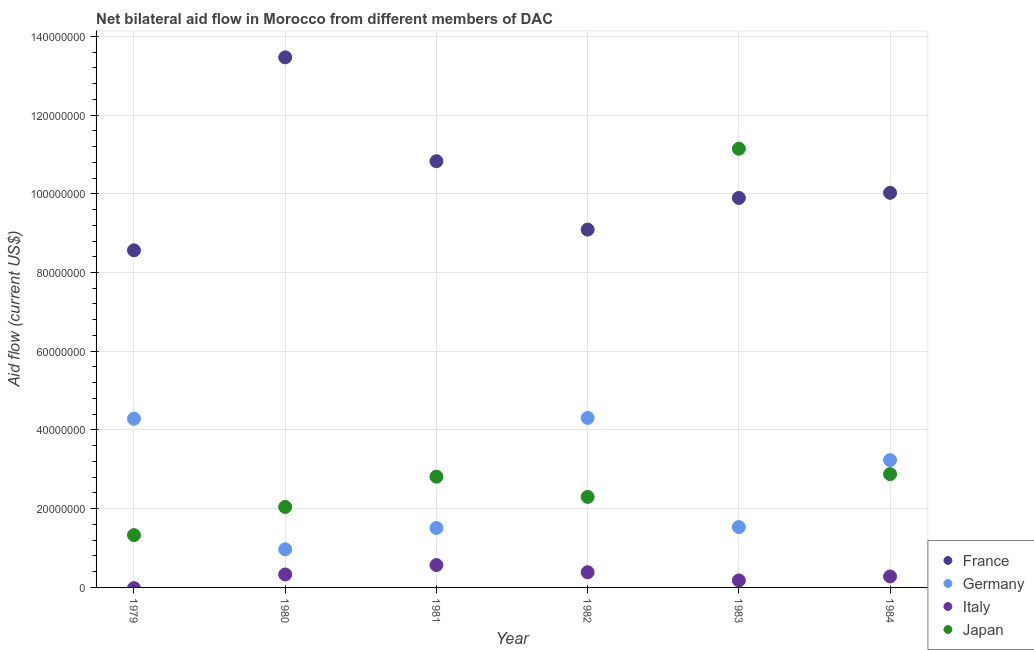What is the amount of aid given by france in 1980?
Your response must be concise. 1.35e+08. Across all years, what is the maximum amount of aid given by italy?
Make the answer very short. 5.68e+06. Across all years, what is the minimum amount of aid given by japan?
Give a very brief answer. 1.33e+07. What is the total amount of aid given by italy in the graph?
Your answer should be very brief. 1.74e+07. What is the difference between the amount of aid given by france in 1982 and that in 1984?
Ensure brevity in your answer.  -9.34e+06. What is the difference between the amount of aid given by italy in 1979 and the amount of aid given by japan in 1980?
Keep it short and to the point. -2.04e+07. What is the average amount of aid given by japan per year?
Keep it short and to the point. 3.75e+07. In the year 1984, what is the difference between the amount of aid given by japan and amount of aid given by germany?
Your answer should be very brief. -3.55e+06. In how many years, is the amount of aid given by germany greater than 96000000 US$?
Ensure brevity in your answer.  0. What is the ratio of the amount of aid given by france in 1981 to that in 1983?
Make the answer very short. 1.09. What is the difference between the highest and the second highest amount of aid given by japan?
Offer a very short reply. 8.27e+07. What is the difference between the highest and the lowest amount of aid given by france?
Provide a short and direct response. 4.90e+07. In how many years, is the amount of aid given by japan greater than the average amount of aid given by japan taken over all years?
Give a very brief answer. 1. Is the sum of the amount of aid given by italy in 1981 and 1984 greater than the maximum amount of aid given by france across all years?
Your answer should be compact. No. Is it the case that in every year, the sum of the amount of aid given by france and amount of aid given by japan is greater than the sum of amount of aid given by germany and amount of aid given by italy?
Make the answer very short. Yes. Is it the case that in every year, the sum of the amount of aid given by france and amount of aid given by germany is greater than the amount of aid given by italy?
Offer a terse response. Yes. Does the amount of aid given by france monotonically increase over the years?
Provide a short and direct response. No. Is the amount of aid given by italy strictly less than the amount of aid given by japan over the years?
Keep it short and to the point. Yes. Are the values on the major ticks of Y-axis written in scientific E-notation?
Make the answer very short. No. Does the graph contain any zero values?
Keep it short and to the point. Yes. Does the graph contain grids?
Provide a succinct answer. Yes. How many legend labels are there?
Keep it short and to the point. 4. How are the legend labels stacked?
Your response must be concise. Vertical. What is the title of the graph?
Give a very brief answer. Net bilateral aid flow in Morocco from different members of DAC. Does "Germany" appear as one of the legend labels in the graph?
Provide a short and direct response. Yes. What is the label or title of the Y-axis?
Your answer should be very brief. Aid flow (current US$). What is the Aid flow (current US$) of France in 1979?
Offer a very short reply. 8.56e+07. What is the Aid flow (current US$) in Germany in 1979?
Make the answer very short. 4.28e+07. What is the Aid flow (current US$) in Italy in 1979?
Keep it short and to the point. 0. What is the Aid flow (current US$) in Japan in 1979?
Give a very brief answer. 1.33e+07. What is the Aid flow (current US$) of France in 1980?
Your answer should be very brief. 1.35e+08. What is the Aid flow (current US$) of Germany in 1980?
Give a very brief answer. 9.69e+06. What is the Aid flow (current US$) in Italy in 1980?
Ensure brevity in your answer.  3.29e+06. What is the Aid flow (current US$) of Japan in 1980?
Your answer should be very brief. 2.04e+07. What is the Aid flow (current US$) of France in 1981?
Your answer should be compact. 1.08e+08. What is the Aid flow (current US$) of Germany in 1981?
Your answer should be compact. 1.51e+07. What is the Aid flow (current US$) in Italy in 1981?
Ensure brevity in your answer.  5.68e+06. What is the Aid flow (current US$) in Japan in 1981?
Offer a terse response. 2.81e+07. What is the Aid flow (current US$) of France in 1982?
Your answer should be very brief. 9.09e+07. What is the Aid flow (current US$) of Germany in 1982?
Offer a terse response. 4.30e+07. What is the Aid flow (current US$) of Italy in 1982?
Your response must be concise. 3.86e+06. What is the Aid flow (current US$) of Japan in 1982?
Offer a terse response. 2.30e+07. What is the Aid flow (current US$) in France in 1983?
Your answer should be compact. 9.89e+07. What is the Aid flow (current US$) in Germany in 1983?
Your response must be concise. 1.53e+07. What is the Aid flow (current US$) of Italy in 1983?
Provide a short and direct response. 1.78e+06. What is the Aid flow (current US$) in Japan in 1983?
Your answer should be very brief. 1.11e+08. What is the Aid flow (current US$) in France in 1984?
Make the answer very short. 1.00e+08. What is the Aid flow (current US$) in Germany in 1984?
Keep it short and to the point. 3.23e+07. What is the Aid flow (current US$) in Italy in 1984?
Your answer should be very brief. 2.79e+06. What is the Aid flow (current US$) of Japan in 1984?
Ensure brevity in your answer.  2.88e+07. Across all years, what is the maximum Aid flow (current US$) in France?
Ensure brevity in your answer.  1.35e+08. Across all years, what is the maximum Aid flow (current US$) in Germany?
Keep it short and to the point. 4.30e+07. Across all years, what is the maximum Aid flow (current US$) in Italy?
Offer a very short reply. 5.68e+06. Across all years, what is the maximum Aid flow (current US$) in Japan?
Give a very brief answer. 1.11e+08. Across all years, what is the minimum Aid flow (current US$) of France?
Offer a terse response. 8.56e+07. Across all years, what is the minimum Aid flow (current US$) of Germany?
Your answer should be compact. 9.69e+06. Across all years, what is the minimum Aid flow (current US$) of Japan?
Keep it short and to the point. 1.33e+07. What is the total Aid flow (current US$) in France in the graph?
Provide a succinct answer. 6.19e+08. What is the total Aid flow (current US$) in Germany in the graph?
Your answer should be compact. 1.58e+08. What is the total Aid flow (current US$) of Italy in the graph?
Keep it short and to the point. 1.74e+07. What is the total Aid flow (current US$) in Japan in the graph?
Provide a short and direct response. 2.25e+08. What is the difference between the Aid flow (current US$) in France in 1979 and that in 1980?
Provide a succinct answer. -4.90e+07. What is the difference between the Aid flow (current US$) in Germany in 1979 and that in 1980?
Provide a short and direct response. 3.32e+07. What is the difference between the Aid flow (current US$) in Japan in 1979 and that in 1980?
Keep it short and to the point. -7.15e+06. What is the difference between the Aid flow (current US$) in France in 1979 and that in 1981?
Give a very brief answer. -2.26e+07. What is the difference between the Aid flow (current US$) in Germany in 1979 and that in 1981?
Offer a very short reply. 2.78e+07. What is the difference between the Aid flow (current US$) of Japan in 1979 and that in 1981?
Make the answer very short. -1.48e+07. What is the difference between the Aid flow (current US$) of France in 1979 and that in 1982?
Provide a succinct answer. -5.27e+06. What is the difference between the Aid flow (current US$) of Germany in 1979 and that in 1982?
Make the answer very short. -2.00e+05. What is the difference between the Aid flow (current US$) of Japan in 1979 and that in 1982?
Provide a short and direct response. -9.70e+06. What is the difference between the Aid flow (current US$) of France in 1979 and that in 1983?
Your answer should be very brief. -1.33e+07. What is the difference between the Aid flow (current US$) in Germany in 1979 and that in 1983?
Keep it short and to the point. 2.75e+07. What is the difference between the Aid flow (current US$) in Japan in 1979 and that in 1983?
Ensure brevity in your answer.  -9.82e+07. What is the difference between the Aid flow (current US$) of France in 1979 and that in 1984?
Your answer should be compact. -1.46e+07. What is the difference between the Aid flow (current US$) in Germany in 1979 and that in 1984?
Give a very brief answer. 1.05e+07. What is the difference between the Aid flow (current US$) of Japan in 1979 and that in 1984?
Your response must be concise. -1.55e+07. What is the difference between the Aid flow (current US$) of France in 1980 and that in 1981?
Offer a terse response. 2.64e+07. What is the difference between the Aid flow (current US$) in Germany in 1980 and that in 1981?
Your answer should be compact. -5.41e+06. What is the difference between the Aid flow (current US$) of Italy in 1980 and that in 1981?
Provide a succinct answer. -2.39e+06. What is the difference between the Aid flow (current US$) in Japan in 1980 and that in 1981?
Your answer should be compact. -7.69e+06. What is the difference between the Aid flow (current US$) of France in 1980 and that in 1982?
Offer a very short reply. 4.38e+07. What is the difference between the Aid flow (current US$) in Germany in 1980 and that in 1982?
Keep it short and to the point. -3.34e+07. What is the difference between the Aid flow (current US$) of Italy in 1980 and that in 1982?
Provide a short and direct response. -5.70e+05. What is the difference between the Aid flow (current US$) in Japan in 1980 and that in 1982?
Give a very brief answer. -2.55e+06. What is the difference between the Aid flow (current US$) of France in 1980 and that in 1983?
Your response must be concise. 3.57e+07. What is the difference between the Aid flow (current US$) in Germany in 1980 and that in 1983?
Ensure brevity in your answer.  -5.64e+06. What is the difference between the Aid flow (current US$) in Italy in 1980 and that in 1983?
Provide a short and direct response. 1.51e+06. What is the difference between the Aid flow (current US$) of Japan in 1980 and that in 1983?
Your response must be concise. -9.10e+07. What is the difference between the Aid flow (current US$) of France in 1980 and that in 1984?
Ensure brevity in your answer.  3.44e+07. What is the difference between the Aid flow (current US$) of Germany in 1980 and that in 1984?
Make the answer very short. -2.26e+07. What is the difference between the Aid flow (current US$) in Italy in 1980 and that in 1984?
Ensure brevity in your answer.  5.00e+05. What is the difference between the Aid flow (current US$) in Japan in 1980 and that in 1984?
Offer a terse response. -8.34e+06. What is the difference between the Aid flow (current US$) of France in 1981 and that in 1982?
Offer a terse response. 1.74e+07. What is the difference between the Aid flow (current US$) in Germany in 1981 and that in 1982?
Your answer should be compact. -2.80e+07. What is the difference between the Aid flow (current US$) of Italy in 1981 and that in 1982?
Provide a succinct answer. 1.82e+06. What is the difference between the Aid flow (current US$) of Japan in 1981 and that in 1982?
Your answer should be compact. 5.14e+06. What is the difference between the Aid flow (current US$) in France in 1981 and that in 1983?
Ensure brevity in your answer.  9.33e+06. What is the difference between the Aid flow (current US$) in Italy in 1981 and that in 1983?
Provide a succinct answer. 3.90e+06. What is the difference between the Aid flow (current US$) in Japan in 1981 and that in 1983?
Keep it short and to the point. -8.33e+07. What is the difference between the Aid flow (current US$) of France in 1981 and that in 1984?
Make the answer very short. 8.03e+06. What is the difference between the Aid flow (current US$) in Germany in 1981 and that in 1984?
Your response must be concise. -1.72e+07. What is the difference between the Aid flow (current US$) in Italy in 1981 and that in 1984?
Ensure brevity in your answer.  2.89e+06. What is the difference between the Aid flow (current US$) in Japan in 1981 and that in 1984?
Offer a very short reply. -6.50e+05. What is the difference between the Aid flow (current US$) in France in 1982 and that in 1983?
Your answer should be compact. -8.04e+06. What is the difference between the Aid flow (current US$) of Germany in 1982 and that in 1983?
Keep it short and to the point. 2.77e+07. What is the difference between the Aid flow (current US$) of Italy in 1982 and that in 1983?
Keep it short and to the point. 2.08e+06. What is the difference between the Aid flow (current US$) in Japan in 1982 and that in 1983?
Offer a very short reply. -8.84e+07. What is the difference between the Aid flow (current US$) in France in 1982 and that in 1984?
Your response must be concise. -9.34e+06. What is the difference between the Aid flow (current US$) in Germany in 1982 and that in 1984?
Give a very brief answer. 1.07e+07. What is the difference between the Aid flow (current US$) in Italy in 1982 and that in 1984?
Give a very brief answer. 1.07e+06. What is the difference between the Aid flow (current US$) of Japan in 1982 and that in 1984?
Provide a succinct answer. -5.79e+06. What is the difference between the Aid flow (current US$) in France in 1983 and that in 1984?
Your response must be concise. -1.30e+06. What is the difference between the Aid flow (current US$) of Germany in 1983 and that in 1984?
Offer a terse response. -1.70e+07. What is the difference between the Aid flow (current US$) in Italy in 1983 and that in 1984?
Make the answer very short. -1.01e+06. What is the difference between the Aid flow (current US$) in Japan in 1983 and that in 1984?
Ensure brevity in your answer.  8.27e+07. What is the difference between the Aid flow (current US$) in France in 1979 and the Aid flow (current US$) in Germany in 1980?
Offer a terse response. 7.59e+07. What is the difference between the Aid flow (current US$) in France in 1979 and the Aid flow (current US$) in Italy in 1980?
Ensure brevity in your answer.  8.23e+07. What is the difference between the Aid flow (current US$) of France in 1979 and the Aid flow (current US$) of Japan in 1980?
Keep it short and to the point. 6.52e+07. What is the difference between the Aid flow (current US$) of Germany in 1979 and the Aid flow (current US$) of Italy in 1980?
Give a very brief answer. 3.96e+07. What is the difference between the Aid flow (current US$) of Germany in 1979 and the Aid flow (current US$) of Japan in 1980?
Make the answer very short. 2.24e+07. What is the difference between the Aid flow (current US$) of France in 1979 and the Aid flow (current US$) of Germany in 1981?
Give a very brief answer. 7.05e+07. What is the difference between the Aid flow (current US$) in France in 1979 and the Aid flow (current US$) in Italy in 1981?
Ensure brevity in your answer.  8.00e+07. What is the difference between the Aid flow (current US$) in France in 1979 and the Aid flow (current US$) in Japan in 1981?
Your response must be concise. 5.75e+07. What is the difference between the Aid flow (current US$) of Germany in 1979 and the Aid flow (current US$) of Italy in 1981?
Make the answer very short. 3.72e+07. What is the difference between the Aid flow (current US$) in Germany in 1979 and the Aid flow (current US$) in Japan in 1981?
Keep it short and to the point. 1.47e+07. What is the difference between the Aid flow (current US$) of France in 1979 and the Aid flow (current US$) of Germany in 1982?
Provide a succinct answer. 4.26e+07. What is the difference between the Aid flow (current US$) in France in 1979 and the Aid flow (current US$) in Italy in 1982?
Offer a terse response. 8.18e+07. What is the difference between the Aid flow (current US$) in France in 1979 and the Aid flow (current US$) in Japan in 1982?
Your answer should be very brief. 6.26e+07. What is the difference between the Aid flow (current US$) of Germany in 1979 and the Aid flow (current US$) of Italy in 1982?
Provide a short and direct response. 3.90e+07. What is the difference between the Aid flow (current US$) of Germany in 1979 and the Aid flow (current US$) of Japan in 1982?
Offer a terse response. 1.99e+07. What is the difference between the Aid flow (current US$) in France in 1979 and the Aid flow (current US$) in Germany in 1983?
Ensure brevity in your answer.  7.03e+07. What is the difference between the Aid flow (current US$) of France in 1979 and the Aid flow (current US$) of Italy in 1983?
Your response must be concise. 8.38e+07. What is the difference between the Aid flow (current US$) of France in 1979 and the Aid flow (current US$) of Japan in 1983?
Provide a succinct answer. -2.58e+07. What is the difference between the Aid flow (current US$) of Germany in 1979 and the Aid flow (current US$) of Italy in 1983?
Your response must be concise. 4.11e+07. What is the difference between the Aid flow (current US$) of Germany in 1979 and the Aid flow (current US$) of Japan in 1983?
Offer a terse response. -6.86e+07. What is the difference between the Aid flow (current US$) in France in 1979 and the Aid flow (current US$) in Germany in 1984?
Offer a very short reply. 5.33e+07. What is the difference between the Aid flow (current US$) in France in 1979 and the Aid flow (current US$) in Italy in 1984?
Provide a short and direct response. 8.28e+07. What is the difference between the Aid flow (current US$) of France in 1979 and the Aid flow (current US$) of Japan in 1984?
Your answer should be very brief. 5.68e+07. What is the difference between the Aid flow (current US$) in Germany in 1979 and the Aid flow (current US$) in Italy in 1984?
Provide a short and direct response. 4.01e+07. What is the difference between the Aid flow (current US$) in Germany in 1979 and the Aid flow (current US$) in Japan in 1984?
Provide a short and direct response. 1.41e+07. What is the difference between the Aid flow (current US$) of France in 1980 and the Aid flow (current US$) of Germany in 1981?
Offer a terse response. 1.20e+08. What is the difference between the Aid flow (current US$) of France in 1980 and the Aid flow (current US$) of Italy in 1981?
Give a very brief answer. 1.29e+08. What is the difference between the Aid flow (current US$) in France in 1980 and the Aid flow (current US$) in Japan in 1981?
Ensure brevity in your answer.  1.07e+08. What is the difference between the Aid flow (current US$) of Germany in 1980 and the Aid flow (current US$) of Italy in 1981?
Offer a terse response. 4.01e+06. What is the difference between the Aid flow (current US$) of Germany in 1980 and the Aid flow (current US$) of Japan in 1981?
Make the answer very short. -1.84e+07. What is the difference between the Aid flow (current US$) in Italy in 1980 and the Aid flow (current US$) in Japan in 1981?
Give a very brief answer. -2.48e+07. What is the difference between the Aid flow (current US$) of France in 1980 and the Aid flow (current US$) of Germany in 1982?
Your response must be concise. 9.16e+07. What is the difference between the Aid flow (current US$) of France in 1980 and the Aid flow (current US$) of Italy in 1982?
Provide a short and direct response. 1.31e+08. What is the difference between the Aid flow (current US$) in France in 1980 and the Aid flow (current US$) in Japan in 1982?
Provide a succinct answer. 1.12e+08. What is the difference between the Aid flow (current US$) of Germany in 1980 and the Aid flow (current US$) of Italy in 1982?
Ensure brevity in your answer.  5.83e+06. What is the difference between the Aid flow (current US$) in Germany in 1980 and the Aid flow (current US$) in Japan in 1982?
Offer a very short reply. -1.33e+07. What is the difference between the Aid flow (current US$) in Italy in 1980 and the Aid flow (current US$) in Japan in 1982?
Offer a terse response. -1.97e+07. What is the difference between the Aid flow (current US$) of France in 1980 and the Aid flow (current US$) of Germany in 1983?
Your answer should be very brief. 1.19e+08. What is the difference between the Aid flow (current US$) in France in 1980 and the Aid flow (current US$) in Italy in 1983?
Your response must be concise. 1.33e+08. What is the difference between the Aid flow (current US$) in France in 1980 and the Aid flow (current US$) in Japan in 1983?
Provide a succinct answer. 2.32e+07. What is the difference between the Aid flow (current US$) of Germany in 1980 and the Aid flow (current US$) of Italy in 1983?
Offer a terse response. 7.91e+06. What is the difference between the Aid flow (current US$) of Germany in 1980 and the Aid flow (current US$) of Japan in 1983?
Keep it short and to the point. -1.02e+08. What is the difference between the Aid flow (current US$) of Italy in 1980 and the Aid flow (current US$) of Japan in 1983?
Offer a terse response. -1.08e+08. What is the difference between the Aid flow (current US$) of France in 1980 and the Aid flow (current US$) of Germany in 1984?
Offer a terse response. 1.02e+08. What is the difference between the Aid flow (current US$) of France in 1980 and the Aid flow (current US$) of Italy in 1984?
Your answer should be compact. 1.32e+08. What is the difference between the Aid flow (current US$) in France in 1980 and the Aid flow (current US$) in Japan in 1984?
Provide a short and direct response. 1.06e+08. What is the difference between the Aid flow (current US$) in Germany in 1980 and the Aid flow (current US$) in Italy in 1984?
Make the answer very short. 6.90e+06. What is the difference between the Aid flow (current US$) of Germany in 1980 and the Aid flow (current US$) of Japan in 1984?
Provide a short and direct response. -1.91e+07. What is the difference between the Aid flow (current US$) of Italy in 1980 and the Aid flow (current US$) of Japan in 1984?
Your response must be concise. -2.55e+07. What is the difference between the Aid flow (current US$) in France in 1981 and the Aid flow (current US$) in Germany in 1982?
Keep it short and to the point. 6.52e+07. What is the difference between the Aid flow (current US$) in France in 1981 and the Aid flow (current US$) in Italy in 1982?
Give a very brief answer. 1.04e+08. What is the difference between the Aid flow (current US$) in France in 1981 and the Aid flow (current US$) in Japan in 1982?
Give a very brief answer. 8.53e+07. What is the difference between the Aid flow (current US$) of Germany in 1981 and the Aid flow (current US$) of Italy in 1982?
Provide a short and direct response. 1.12e+07. What is the difference between the Aid flow (current US$) of Germany in 1981 and the Aid flow (current US$) of Japan in 1982?
Provide a succinct answer. -7.89e+06. What is the difference between the Aid flow (current US$) of Italy in 1981 and the Aid flow (current US$) of Japan in 1982?
Give a very brief answer. -1.73e+07. What is the difference between the Aid flow (current US$) in France in 1981 and the Aid flow (current US$) in Germany in 1983?
Provide a succinct answer. 9.29e+07. What is the difference between the Aid flow (current US$) in France in 1981 and the Aid flow (current US$) in Italy in 1983?
Give a very brief answer. 1.06e+08. What is the difference between the Aid flow (current US$) in France in 1981 and the Aid flow (current US$) in Japan in 1983?
Your response must be concise. -3.17e+06. What is the difference between the Aid flow (current US$) in Germany in 1981 and the Aid flow (current US$) in Italy in 1983?
Make the answer very short. 1.33e+07. What is the difference between the Aid flow (current US$) in Germany in 1981 and the Aid flow (current US$) in Japan in 1983?
Offer a very short reply. -9.63e+07. What is the difference between the Aid flow (current US$) in Italy in 1981 and the Aid flow (current US$) in Japan in 1983?
Give a very brief answer. -1.06e+08. What is the difference between the Aid flow (current US$) of France in 1981 and the Aid flow (current US$) of Germany in 1984?
Offer a terse response. 7.59e+07. What is the difference between the Aid flow (current US$) in France in 1981 and the Aid flow (current US$) in Italy in 1984?
Give a very brief answer. 1.05e+08. What is the difference between the Aid flow (current US$) in France in 1981 and the Aid flow (current US$) in Japan in 1984?
Provide a short and direct response. 7.95e+07. What is the difference between the Aid flow (current US$) in Germany in 1981 and the Aid flow (current US$) in Italy in 1984?
Give a very brief answer. 1.23e+07. What is the difference between the Aid flow (current US$) of Germany in 1981 and the Aid flow (current US$) of Japan in 1984?
Keep it short and to the point. -1.37e+07. What is the difference between the Aid flow (current US$) in Italy in 1981 and the Aid flow (current US$) in Japan in 1984?
Ensure brevity in your answer.  -2.31e+07. What is the difference between the Aid flow (current US$) of France in 1982 and the Aid flow (current US$) of Germany in 1983?
Provide a short and direct response. 7.56e+07. What is the difference between the Aid flow (current US$) of France in 1982 and the Aid flow (current US$) of Italy in 1983?
Keep it short and to the point. 8.91e+07. What is the difference between the Aid flow (current US$) of France in 1982 and the Aid flow (current US$) of Japan in 1983?
Make the answer very short. -2.05e+07. What is the difference between the Aid flow (current US$) in Germany in 1982 and the Aid flow (current US$) in Italy in 1983?
Provide a short and direct response. 4.13e+07. What is the difference between the Aid flow (current US$) of Germany in 1982 and the Aid flow (current US$) of Japan in 1983?
Offer a terse response. -6.84e+07. What is the difference between the Aid flow (current US$) of Italy in 1982 and the Aid flow (current US$) of Japan in 1983?
Offer a very short reply. -1.08e+08. What is the difference between the Aid flow (current US$) in France in 1982 and the Aid flow (current US$) in Germany in 1984?
Your answer should be compact. 5.86e+07. What is the difference between the Aid flow (current US$) in France in 1982 and the Aid flow (current US$) in Italy in 1984?
Make the answer very short. 8.81e+07. What is the difference between the Aid flow (current US$) in France in 1982 and the Aid flow (current US$) in Japan in 1984?
Make the answer very short. 6.21e+07. What is the difference between the Aid flow (current US$) of Germany in 1982 and the Aid flow (current US$) of Italy in 1984?
Provide a short and direct response. 4.03e+07. What is the difference between the Aid flow (current US$) in Germany in 1982 and the Aid flow (current US$) in Japan in 1984?
Offer a very short reply. 1.43e+07. What is the difference between the Aid flow (current US$) in Italy in 1982 and the Aid flow (current US$) in Japan in 1984?
Provide a succinct answer. -2.49e+07. What is the difference between the Aid flow (current US$) of France in 1983 and the Aid flow (current US$) of Germany in 1984?
Keep it short and to the point. 6.66e+07. What is the difference between the Aid flow (current US$) of France in 1983 and the Aid flow (current US$) of Italy in 1984?
Ensure brevity in your answer.  9.62e+07. What is the difference between the Aid flow (current US$) in France in 1983 and the Aid flow (current US$) in Japan in 1984?
Offer a terse response. 7.02e+07. What is the difference between the Aid flow (current US$) of Germany in 1983 and the Aid flow (current US$) of Italy in 1984?
Offer a terse response. 1.25e+07. What is the difference between the Aid flow (current US$) of Germany in 1983 and the Aid flow (current US$) of Japan in 1984?
Provide a succinct answer. -1.34e+07. What is the difference between the Aid flow (current US$) in Italy in 1983 and the Aid flow (current US$) in Japan in 1984?
Provide a short and direct response. -2.70e+07. What is the average Aid flow (current US$) of France per year?
Ensure brevity in your answer.  1.03e+08. What is the average Aid flow (current US$) of Germany per year?
Ensure brevity in your answer.  2.64e+07. What is the average Aid flow (current US$) of Italy per year?
Offer a terse response. 2.90e+06. What is the average Aid flow (current US$) of Japan per year?
Your answer should be very brief. 3.75e+07. In the year 1979, what is the difference between the Aid flow (current US$) of France and Aid flow (current US$) of Germany?
Make the answer very short. 4.28e+07. In the year 1979, what is the difference between the Aid flow (current US$) of France and Aid flow (current US$) of Japan?
Offer a very short reply. 7.23e+07. In the year 1979, what is the difference between the Aid flow (current US$) in Germany and Aid flow (current US$) in Japan?
Ensure brevity in your answer.  2.96e+07. In the year 1980, what is the difference between the Aid flow (current US$) of France and Aid flow (current US$) of Germany?
Give a very brief answer. 1.25e+08. In the year 1980, what is the difference between the Aid flow (current US$) in France and Aid flow (current US$) in Italy?
Provide a short and direct response. 1.31e+08. In the year 1980, what is the difference between the Aid flow (current US$) of France and Aid flow (current US$) of Japan?
Provide a succinct answer. 1.14e+08. In the year 1980, what is the difference between the Aid flow (current US$) in Germany and Aid flow (current US$) in Italy?
Provide a succinct answer. 6.40e+06. In the year 1980, what is the difference between the Aid flow (current US$) in Germany and Aid flow (current US$) in Japan?
Your answer should be compact. -1.08e+07. In the year 1980, what is the difference between the Aid flow (current US$) in Italy and Aid flow (current US$) in Japan?
Your response must be concise. -1.72e+07. In the year 1981, what is the difference between the Aid flow (current US$) of France and Aid flow (current US$) of Germany?
Your answer should be very brief. 9.32e+07. In the year 1981, what is the difference between the Aid flow (current US$) in France and Aid flow (current US$) in Italy?
Offer a very short reply. 1.03e+08. In the year 1981, what is the difference between the Aid flow (current US$) in France and Aid flow (current US$) in Japan?
Your response must be concise. 8.01e+07. In the year 1981, what is the difference between the Aid flow (current US$) in Germany and Aid flow (current US$) in Italy?
Provide a succinct answer. 9.42e+06. In the year 1981, what is the difference between the Aid flow (current US$) in Germany and Aid flow (current US$) in Japan?
Make the answer very short. -1.30e+07. In the year 1981, what is the difference between the Aid flow (current US$) in Italy and Aid flow (current US$) in Japan?
Your response must be concise. -2.24e+07. In the year 1982, what is the difference between the Aid flow (current US$) of France and Aid flow (current US$) of Germany?
Make the answer very short. 4.78e+07. In the year 1982, what is the difference between the Aid flow (current US$) in France and Aid flow (current US$) in Italy?
Offer a very short reply. 8.70e+07. In the year 1982, what is the difference between the Aid flow (current US$) of France and Aid flow (current US$) of Japan?
Your answer should be compact. 6.79e+07. In the year 1982, what is the difference between the Aid flow (current US$) of Germany and Aid flow (current US$) of Italy?
Give a very brief answer. 3.92e+07. In the year 1982, what is the difference between the Aid flow (current US$) of Germany and Aid flow (current US$) of Japan?
Offer a very short reply. 2.01e+07. In the year 1982, what is the difference between the Aid flow (current US$) in Italy and Aid flow (current US$) in Japan?
Your answer should be compact. -1.91e+07. In the year 1983, what is the difference between the Aid flow (current US$) in France and Aid flow (current US$) in Germany?
Provide a succinct answer. 8.36e+07. In the year 1983, what is the difference between the Aid flow (current US$) in France and Aid flow (current US$) in Italy?
Make the answer very short. 9.72e+07. In the year 1983, what is the difference between the Aid flow (current US$) in France and Aid flow (current US$) in Japan?
Make the answer very short. -1.25e+07. In the year 1983, what is the difference between the Aid flow (current US$) in Germany and Aid flow (current US$) in Italy?
Keep it short and to the point. 1.36e+07. In the year 1983, what is the difference between the Aid flow (current US$) in Germany and Aid flow (current US$) in Japan?
Your answer should be compact. -9.61e+07. In the year 1983, what is the difference between the Aid flow (current US$) of Italy and Aid flow (current US$) of Japan?
Offer a terse response. -1.10e+08. In the year 1984, what is the difference between the Aid flow (current US$) in France and Aid flow (current US$) in Germany?
Offer a very short reply. 6.79e+07. In the year 1984, what is the difference between the Aid flow (current US$) in France and Aid flow (current US$) in Italy?
Your answer should be very brief. 9.74e+07. In the year 1984, what is the difference between the Aid flow (current US$) of France and Aid flow (current US$) of Japan?
Your response must be concise. 7.15e+07. In the year 1984, what is the difference between the Aid flow (current US$) of Germany and Aid flow (current US$) of Italy?
Give a very brief answer. 2.95e+07. In the year 1984, what is the difference between the Aid flow (current US$) in Germany and Aid flow (current US$) in Japan?
Ensure brevity in your answer.  3.55e+06. In the year 1984, what is the difference between the Aid flow (current US$) of Italy and Aid flow (current US$) of Japan?
Your answer should be very brief. -2.60e+07. What is the ratio of the Aid flow (current US$) in France in 1979 to that in 1980?
Provide a succinct answer. 0.64. What is the ratio of the Aid flow (current US$) of Germany in 1979 to that in 1980?
Make the answer very short. 4.42. What is the ratio of the Aid flow (current US$) in Japan in 1979 to that in 1980?
Provide a succinct answer. 0.65. What is the ratio of the Aid flow (current US$) in France in 1979 to that in 1981?
Your response must be concise. 0.79. What is the ratio of the Aid flow (current US$) of Germany in 1979 to that in 1981?
Offer a very short reply. 2.84. What is the ratio of the Aid flow (current US$) of Japan in 1979 to that in 1981?
Ensure brevity in your answer.  0.47. What is the ratio of the Aid flow (current US$) in France in 1979 to that in 1982?
Offer a terse response. 0.94. What is the ratio of the Aid flow (current US$) of Japan in 1979 to that in 1982?
Your response must be concise. 0.58. What is the ratio of the Aid flow (current US$) of France in 1979 to that in 1983?
Make the answer very short. 0.87. What is the ratio of the Aid flow (current US$) in Germany in 1979 to that in 1983?
Ensure brevity in your answer.  2.8. What is the ratio of the Aid flow (current US$) of Japan in 1979 to that in 1983?
Your answer should be compact. 0.12. What is the ratio of the Aid flow (current US$) in France in 1979 to that in 1984?
Keep it short and to the point. 0.85. What is the ratio of the Aid flow (current US$) in Germany in 1979 to that in 1984?
Your answer should be compact. 1.33. What is the ratio of the Aid flow (current US$) of Japan in 1979 to that in 1984?
Give a very brief answer. 0.46. What is the ratio of the Aid flow (current US$) in France in 1980 to that in 1981?
Provide a succinct answer. 1.24. What is the ratio of the Aid flow (current US$) of Germany in 1980 to that in 1981?
Your answer should be very brief. 0.64. What is the ratio of the Aid flow (current US$) in Italy in 1980 to that in 1981?
Your answer should be compact. 0.58. What is the ratio of the Aid flow (current US$) of Japan in 1980 to that in 1981?
Give a very brief answer. 0.73. What is the ratio of the Aid flow (current US$) in France in 1980 to that in 1982?
Your answer should be compact. 1.48. What is the ratio of the Aid flow (current US$) of Germany in 1980 to that in 1982?
Give a very brief answer. 0.23. What is the ratio of the Aid flow (current US$) of Italy in 1980 to that in 1982?
Make the answer very short. 0.85. What is the ratio of the Aid flow (current US$) in Japan in 1980 to that in 1982?
Provide a succinct answer. 0.89. What is the ratio of the Aid flow (current US$) in France in 1980 to that in 1983?
Your response must be concise. 1.36. What is the ratio of the Aid flow (current US$) of Germany in 1980 to that in 1983?
Your answer should be very brief. 0.63. What is the ratio of the Aid flow (current US$) in Italy in 1980 to that in 1983?
Your answer should be compact. 1.85. What is the ratio of the Aid flow (current US$) of Japan in 1980 to that in 1983?
Offer a very short reply. 0.18. What is the ratio of the Aid flow (current US$) in France in 1980 to that in 1984?
Your response must be concise. 1.34. What is the ratio of the Aid flow (current US$) in Germany in 1980 to that in 1984?
Give a very brief answer. 0.3. What is the ratio of the Aid flow (current US$) in Italy in 1980 to that in 1984?
Provide a succinct answer. 1.18. What is the ratio of the Aid flow (current US$) of Japan in 1980 to that in 1984?
Your answer should be very brief. 0.71. What is the ratio of the Aid flow (current US$) in France in 1981 to that in 1982?
Offer a terse response. 1.19. What is the ratio of the Aid flow (current US$) in Germany in 1981 to that in 1982?
Your response must be concise. 0.35. What is the ratio of the Aid flow (current US$) in Italy in 1981 to that in 1982?
Give a very brief answer. 1.47. What is the ratio of the Aid flow (current US$) of Japan in 1981 to that in 1982?
Make the answer very short. 1.22. What is the ratio of the Aid flow (current US$) of France in 1981 to that in 1983?
Ensure brevity in your answer.  1.09. What is the ratio of the Aid flow (current US$) in Germany in 1981 to that in 1983?
Offer a very short reply. 0.98. What is the ratio of the Aid flow (current US$) of Italy in 1981 to that in 1983?
Provide a succinct answer. 3.19. What is the ratio of the Aid flow (current US$) in Japan in 1981 to that in 1983?
Give a very brief answer. 0.25. What is the ratio of the Aid flow (current US$) of France in 1981 to that in 1984?
Your answer should be compact. 1.08. What is the ratio of the Aid flow (current US$) of Germany in 1981 to that in 1984?
Your answer should be very brief. 0.47. What is the ratio of the Aid flow (current US$) in Italy in 1981 to that in 1984?
Offer a very short reply. 2.04. What is the ratio of the Aid flow (current US$) of Japan in 1981 to that in 1984?
Make the answer very short. 0.98. What is the ratio of the Aid flow (current US$) in France in 1982 to that in 1983?
Ensure brevity in your answer.  0.92. What is the ratio of the Aid flow (current US$) in Germany in 1982 to that in 1983?
Provide a succinct answer. 2.81. What is the ratio of the Aid flow (current US$) in Italy in 1982 to that in 1983?
Ensure brevity in your answer.  2.17. What is the ratio of the Aid flow (current US$) in Japan in 1982 to that in 1983?
Your answer should be very brief. 0.21. What is the ratio of the Aid flow (current US$) in France in 1982 to that in 1984?
Keep it short and to the point. 0.91. What is the ratio of the Aid flow (current US$) in Germany in 1982 to that in 1984?
Keep it short and to the point. 1.33. What is the ratio of the Aid flow (current US$) of Italy in 1982 to that in 1984?
Your answer should be very brief. 1.38. What is the ratio of the Aid flow (current US$) of Japan in 1982 to that in 1984?
Keep it short and to the point. 0.8. What is the ratio of the Aid flow (current US$) in Germany in 1983 to that in 1984?
Your answer should be very brief. 0.47. What is the ratio of the Aid flow (current US$) in Italy in 1983 to that in 1984?
Provide a succinct answer. 0.64. What is the ratio of the Aid flow (current US$) in Japan in 1983 to that in 1984?
Provide a short and direct response. 3.87. What is the difference between the highest and the second highest Aid flow (current US$) in France?
Ensure brevity in your answer.  2.64e+07. What is the difference between the highest and the second highest Aid flow (current US$) of Germany?
Your answer should be very brief. 2.00e+05. What is the difference between the highest and the second highest Aid flow (current US$) in Italy?
Provide a succinct answer. 1.82e+06. What is the difference between the highest and the second highest Aid flow (current US$) in Japan?
Offer a terse response. 8.27e+07. What is the difference between the highest and the lowest Aid flow (current US$) in France?
Offer a terse response. 4.90e+07. What is the difference between the highest and the lowest Aid flow (current US$) in Germany?
Ensure brevity in your answer.  3.34e+07. What is the difference between the highest and the lowest Aid flow (current US$) in Italy?
Provide a succinct answer. 5.68e+06. What is the difference between the highest and the lowest Aid flow (current US$) of Japan?
Your response must be concise. 9.82e+07. 